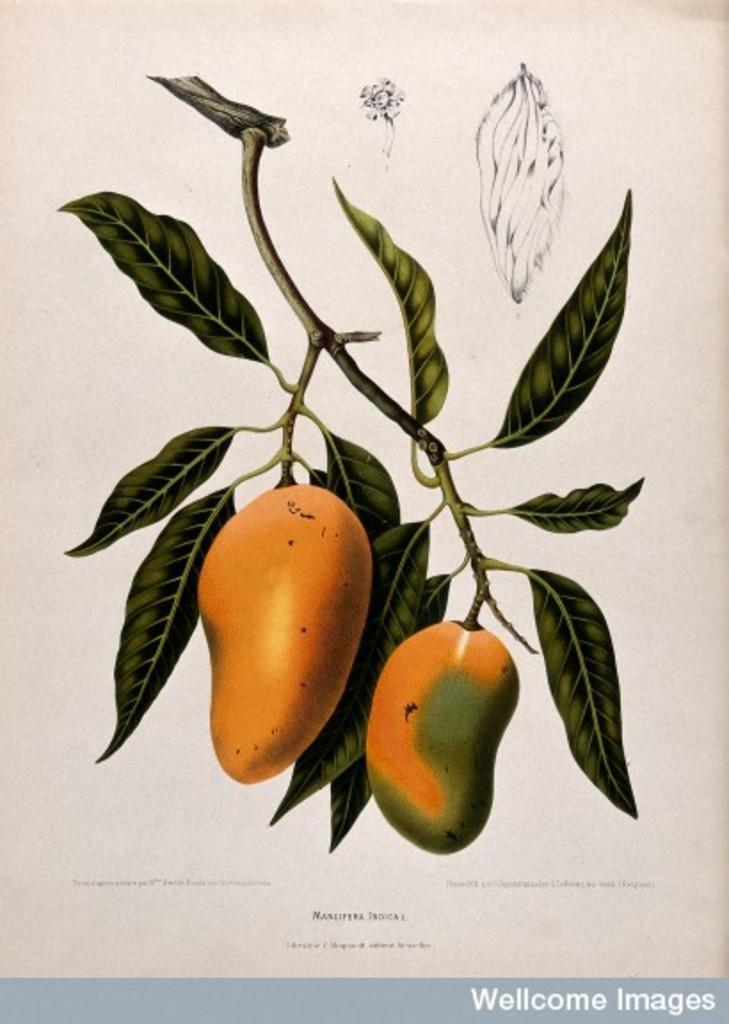Could you give a brief overview of what you see in this image? In this image I can see a animated picture of a mango tree and a text. 